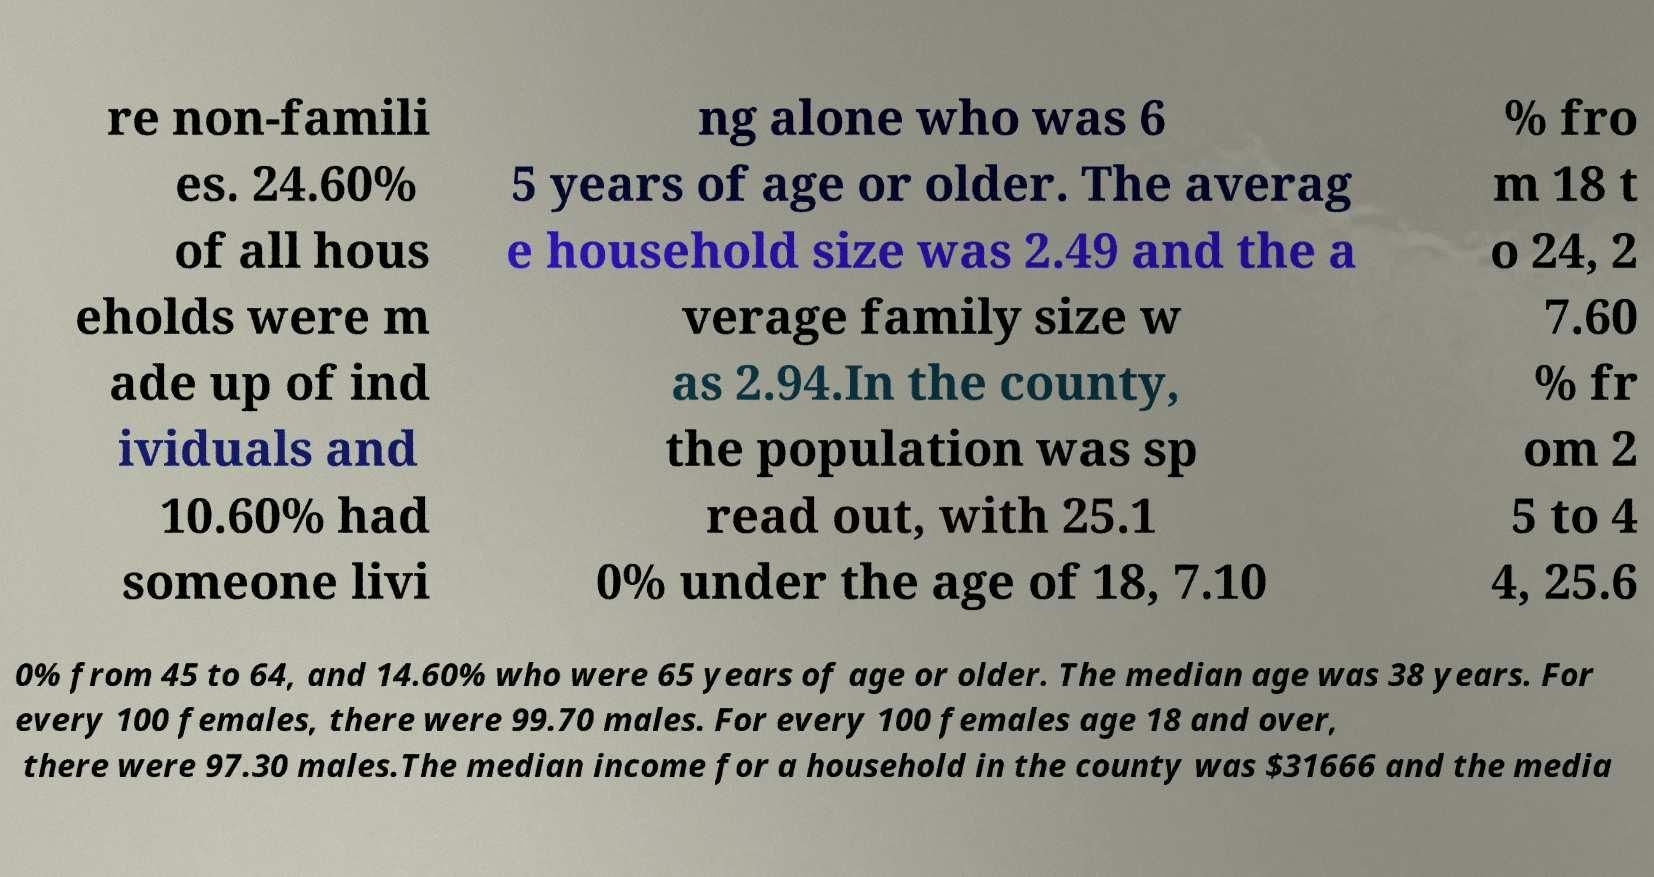What messages or text are displayed in this image? I need them in a readable, typed format. re non-famili es. 24.60% of all hous eholds were m ade up of ind ividuals and 10.60% had someone livi ng alone who was 6 5 years of age or older. The averag e household size was 2.49 and the a verage family size w as 2.94.In the county, the population was sp read out, with 25.1 0% under the age of 18, 7.10 % fro m 18 t o 24, 2 7.60 % fr om 2 5 to 4 4, 25.6 0% from 45 to 64, and 14.60% who were 65 years of age or older. The median age was 38 years. For every 100 females, there were 99.70 males. For every 100 females age 18 and over, there were 97.30 males.The median income for a household in the county was $31666 and the media 